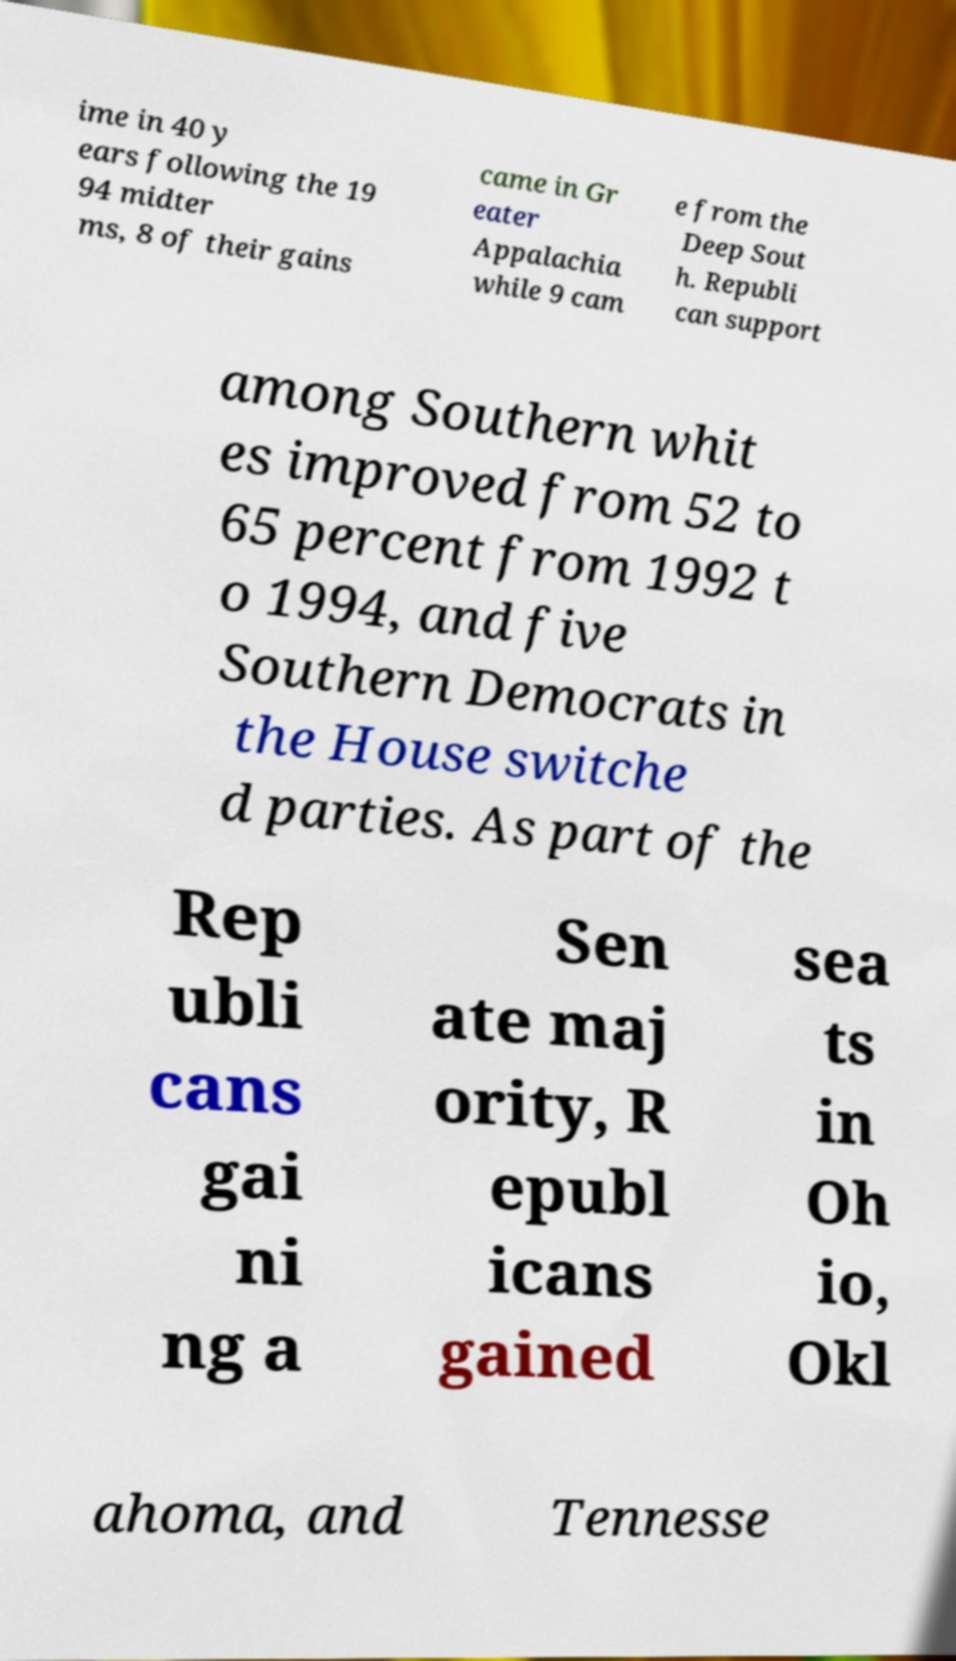For documentation purposes, I need the text within this image transcribed. Could you provide that? ime in 40 y ears following the 19 94 midter ms, 8 of their gains came in Gr eater Appalachia while 9 cam e from the Deep Sout h. Republi can support among Southern whit es improved from 52 to 65 percent from 1992 t o 1994, and five Southern Democrats in the House switche d parties. As part of the Rep ubli cans gai ni ng a Sen ate maj ority, R epubl icans gained sea ts in Oh io, Okl ahoma, and Tennesse 